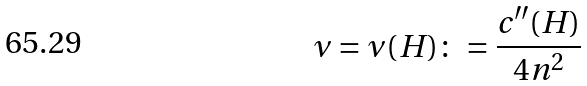Convert formula to latex. <formula><loc_0><loc_0><loc_500><loc_500>\nu = \nu ( H ) \colon = \frac { c ^ { \prime \prime } ( H ) } { 4 n ^ { 2 } }</formula> 